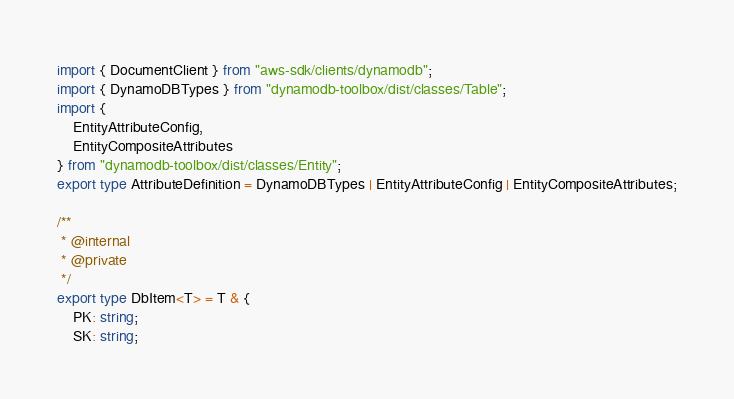Convert code to text. <code><loc_0><loc_0><loc_500><loc_500><_TypeScript_>import { DocumentClient } from "aws-sdk/clients/dynamodb";
import { DynamoDBTypes } from "dynamodb-toolbox/dist/classes/Table";
import {
    EntityAttributeConfig,
    EntityCompositeAttributes
} from "dynamodb-toolbox/dist/classes/Entity";
export type AttributeDefinition = DynamoDBTypes | EntityAttributeConfig | EntityCompositeAttributes;

/**
 * @internal
 * @private
 */
export type DbItem<T> = T & {
    PK: string;
    SK: string;</code> 